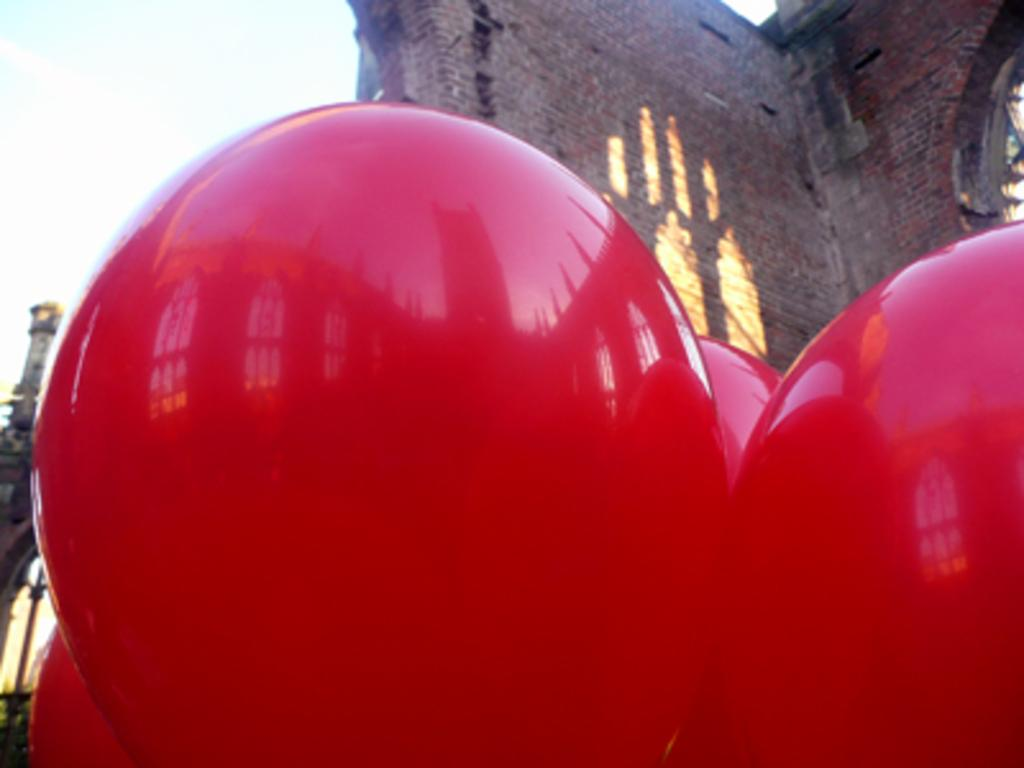What objects are present in the image? There are balloons in the image. What color are the balloons? The balloons are red in color. What can be seen in the background of the image? There is a building and the sky visible in the background of the image. What material is the building made of? The building is made up of bricks. How does the person in the image compare their nose to the balloons? There is no person present in the image, so it is not possible to answer a question about comparing their nose to the balloons. 